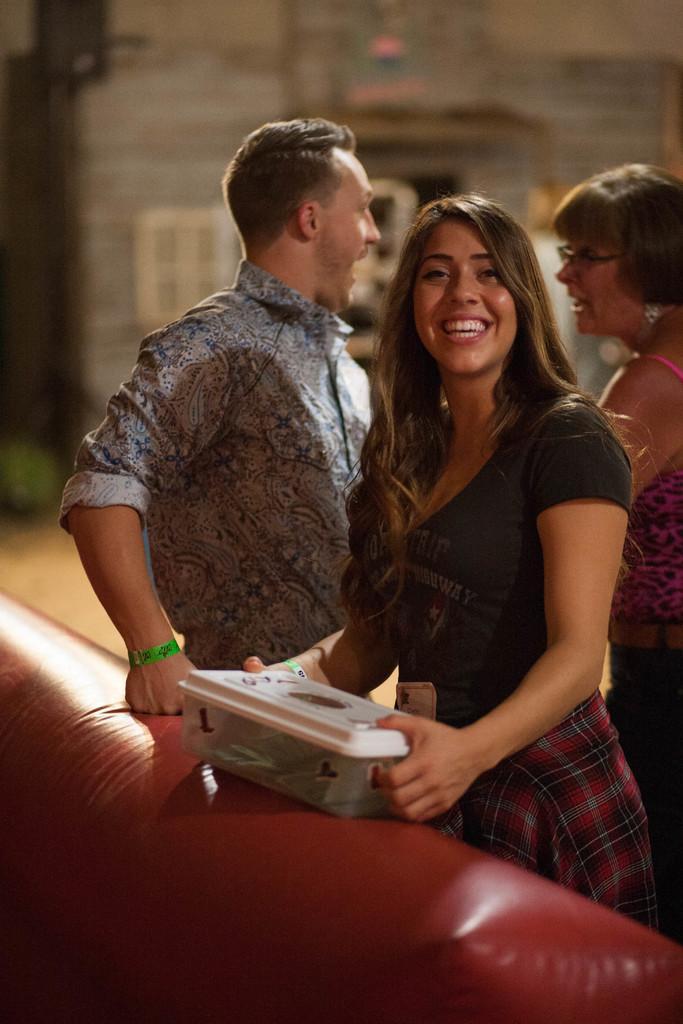Please provide a concise description of this image. In the right side a beautiful woman is standing, she wore dress. She is smiling and in the middle a man is there. He wore a shirt. 